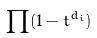<formula> <loc_0><loc_0><loc_500><loc_500>\prod ( 1 - t ^ { d _ { i } } )</formula> 